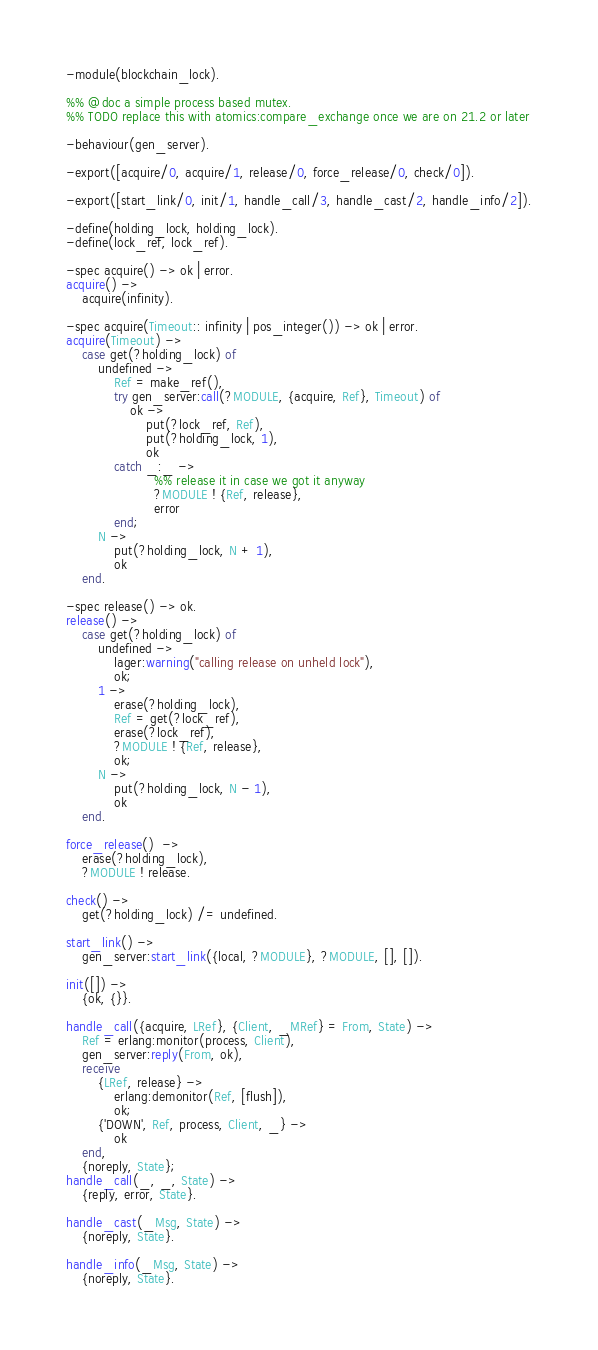Convert code to text. <code><loc_0><loc_0><loc_500><loc_500><_Erlang_>-module(blockchain_lock).

%% @doc a simple process based mutex.
%% TODO replace this with atomics:compare_exchange once we are on 21.2 or later

-behaviour(gen_server).

-export([acquire/0, acquire/1, release/0, force_release/0, check/0]).

-export([start_link/0, init/1, handle_call/3, handle_cast/2, handle_info/2]).

-define(holding_lock, holding_lock).
-define(lock_ref, lock_ref).

-spec acquire() -> ok | error.
acquire() ->
    acquire(infinity).

-spec acquire(Timeout:: infinity | pos_integer()) -> ok | error.
acquire(Timeout) ->
    case get(?holding_lock) of
        undefined ->
            Ref = make_ref(),
            try gen_server:call(?MODULE, {acquire, Ref}, Timeout) of
                ok ->
                    put(?lock_ref, Ref),
                    put(?holding_lock, 1),
                    ok
            catch _:_ ->
                      %% release it in case we got it anyway
                      ?MODULE ! {Ref, release},
                      error
            end;
        N ->
            put(?holding_lock, N + 1),
            ok
    end.

-spec release() -> ok.
release() ->
    case get(?holding_lock) of
        undefined ->
            lager:warning("calling release on unheld lock"),
            ok;
        1 ->
            erase(?holding_lock),
            Ref = get(?lock_ref),
            erase(?lock_ref),
            ?MODULE ! {Ref, release},
            ok;
        N ->
            put(?holding_lock, N - 1),
            ok
    end.

force_release()  ->
    erase(?holding_lock),
    ?MODULE ! release.

check() ->
    get(?holding_lock) /= undefined.

start_link() ->
    gen_server:start_link({local, ?MODULE}, ?MODULE, [], []).

init([]) ->
    {ok, {}}.

handle_call({acquire, LRef}, {Client, _MRef} = From, State) ->
    Ref = erlang:monitor(process, Client),
    gen_server:reply(From, ok),
    receive
        {LRef, release} ->
            erlang:demonitor(Ref, [flush]),
            ok;
        {'DOWN', Ref, process, Client, _} ->
            ok
    end,
    {noreply, State};
handle_call(_, _, State) ->
    {reply, error, State}.

handle_cast(_Msg, State) ->
    {noreply, State}.

handle_info(_Msg, State) ->
    {noreply, State}.
</code> 